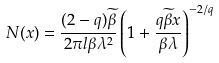<formula> <loc_0><loc_0><loc_500><loc_500>N ( x ) = \frac { ( 2 - q ) \widetilde { \beta } } { 2 \pi l \beta \lambda ^ { 2 } } \left ( 1 + \frac { q \widetilde { \beta } x } { \beta \lambda } \right ) ^ { - 2 / q }</formula> 